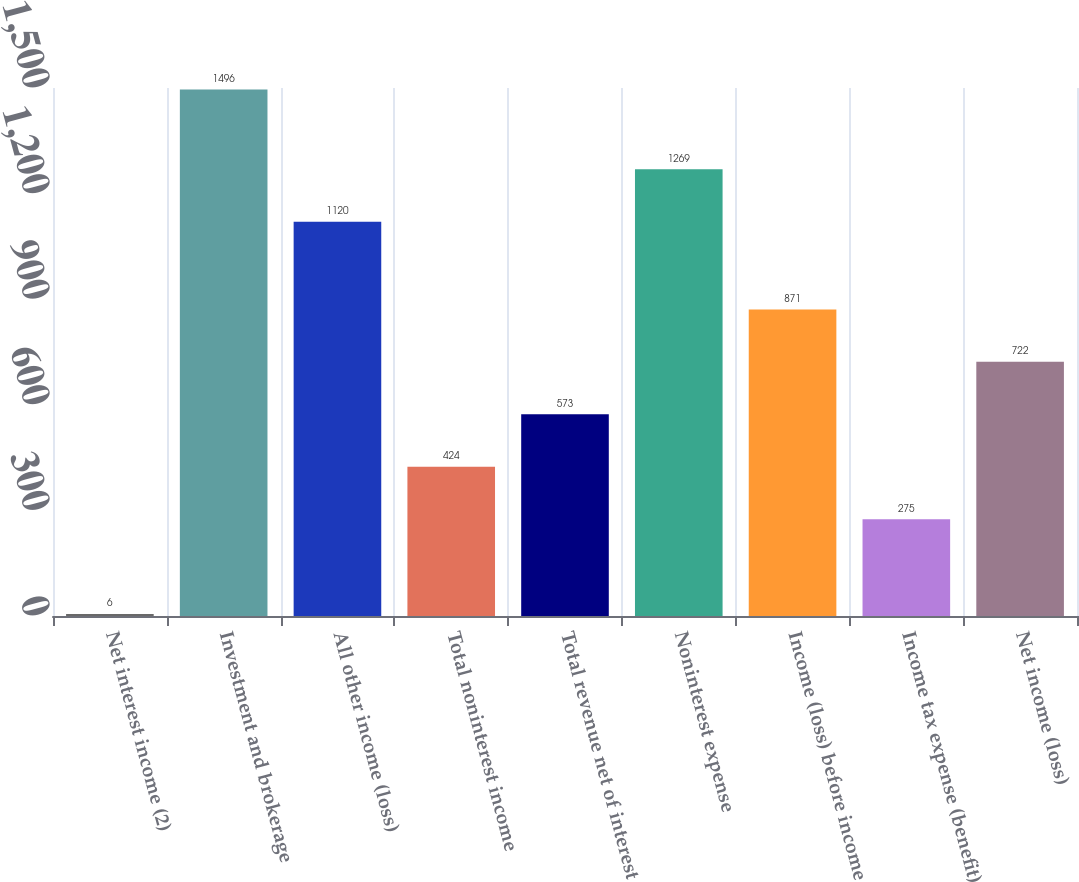<chart> <loc_0><loc_0><loc_500><loc_500><bar_chart><fcel>Net interest income (2)<fcel>Investment and brokerage<fcel>All other income (loss)<fcel>Total noninterest income<fcel>Total revenue net of interest<fcel>Noninterest expense<fcel>Income (loss) before income<fcel>Income tax expense (benefit)<fcel>Net income (loss)<nl><fcel>6<fcel>1496<fcel>1120<fcel>424<fcel>573<fcel>1269<fcel>871<fcel>275<fcel>722<nl></chart> 